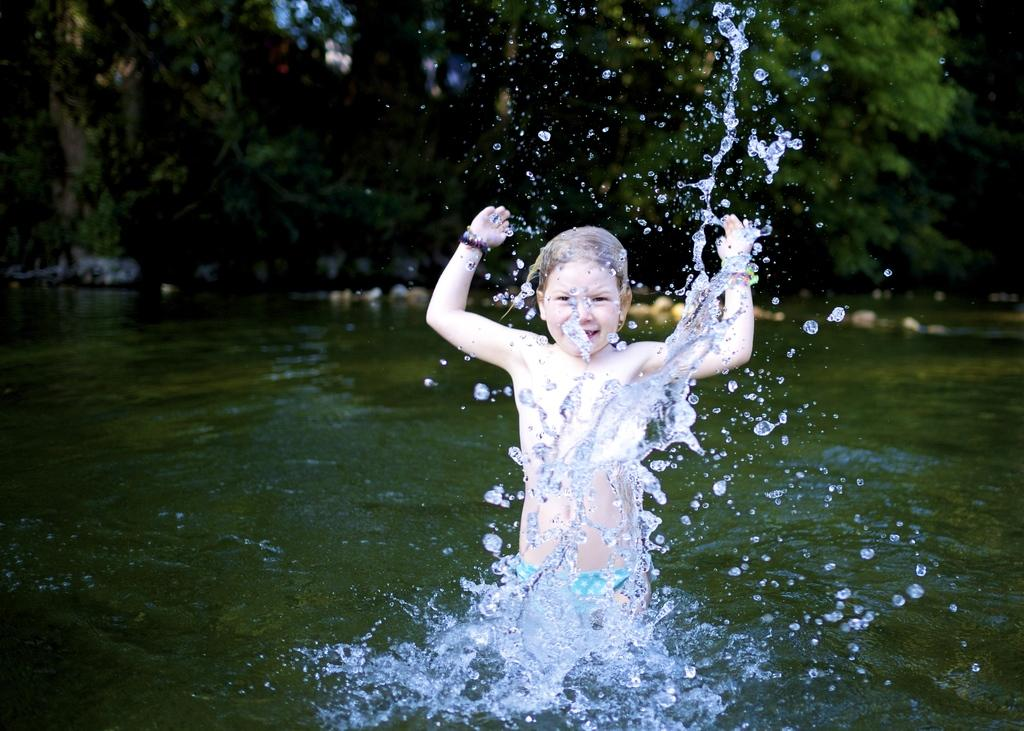What is the child doing in the image? The child is standing in the water. How would you describe the background of the image? The background of the image is blurred. What can be seen in the background of the image? There are trees visible in the background. What type of religious ceremony is taking place in the image? There is no indication of a religious ceremony in the image; it simply shows a child standing in the water. What is the child carrying in the sack in the image? There is no sack present in the image, so it is not possible to answer that question. 